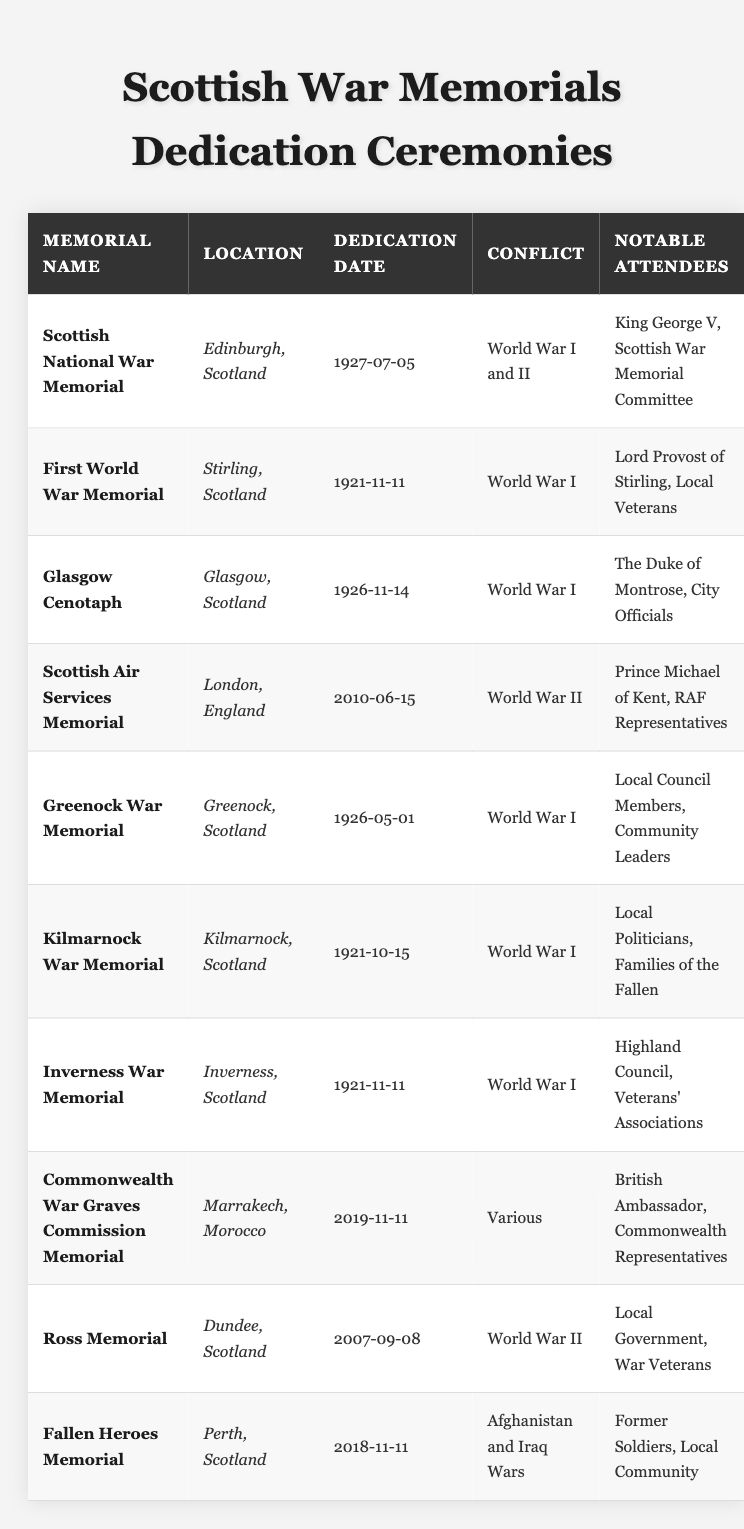What is the dedication date of the Glasgow Cenotaph? The table lists the dedication date of the Glasgow Cenotaph as 1926-11-14, which can be found directly under the relevant column.
Answer: 1926-11-14 How many war memorials were dedicated in 1921? By reviewing the Dedication Date column, I count three memorials (First World War Memorial, Kilmarnock War Memorial, and Inverness War Memorial) that were dedicated in the year 1921.
Answer: 3 Which conflict is associated with the Fallen Heroes Memorial? The table specifies that the Fallen Heroes Memorial is linked to the Afghanistan and Iraq Wars, indicated in the Conflict column.
Answer: Afghanistan and Iraq Wars Did King George V attend the dedication of any war memorial? Yes, the Notable Attendees column indicates that King George V attended the dedication of the Scottish National War Memorial. Therefore, the answer is yes.
Answer: Yes What is the latest dedication date among the memorials listed? After examining the Dedication Date column, I find that the latest date is 2019-11-11, associated with the Commonwealth War Graves Commission Memorial.
Answer: 2019-11-11 Which conflict involved the most memorials from this table? Analyzing the Conflict column, World War I appears to be associated with six memorials, confirming it as the conflict with the most dedications.
Answer: World War I Were there any memorials dedicated in the same year as the Scottish Air Services Memorial? The Scottish Air Services Memorial was dedicated in 2010. Referring to the table, I find no other memorials dedicated that same year, confirming there were none.
Answer: No What percentage of the memorials were dedicated to World War II? There are 10 memorials total, with 2 (Scottish Air Services Memorial and Ross Memorial) dedicated to World War II. The calculation is (2/10) * 100 = 20%.
Answer: 20% List all locations where memorials were dedicated in Scotland. By scanning the Location column, I find that the memorials were dedicated in Edinburgh, Stirling, Glasgow, Greenock, Kilmarnock, Inverness, Dundee, and Perth.
Answer: Edinburgh, Stirling, Glasgow, Greenock, Kilmarnock, Inverness, Dundee, Perth What notable attendees were present at the dedication of the Commonwealth War Graves Commission Memorial? The table indicates that the British Ambassador and Commonwealth Representatives were the notable attendees listed for that memorial.
Answer: British Ambassador, Commonwealth Representatives 